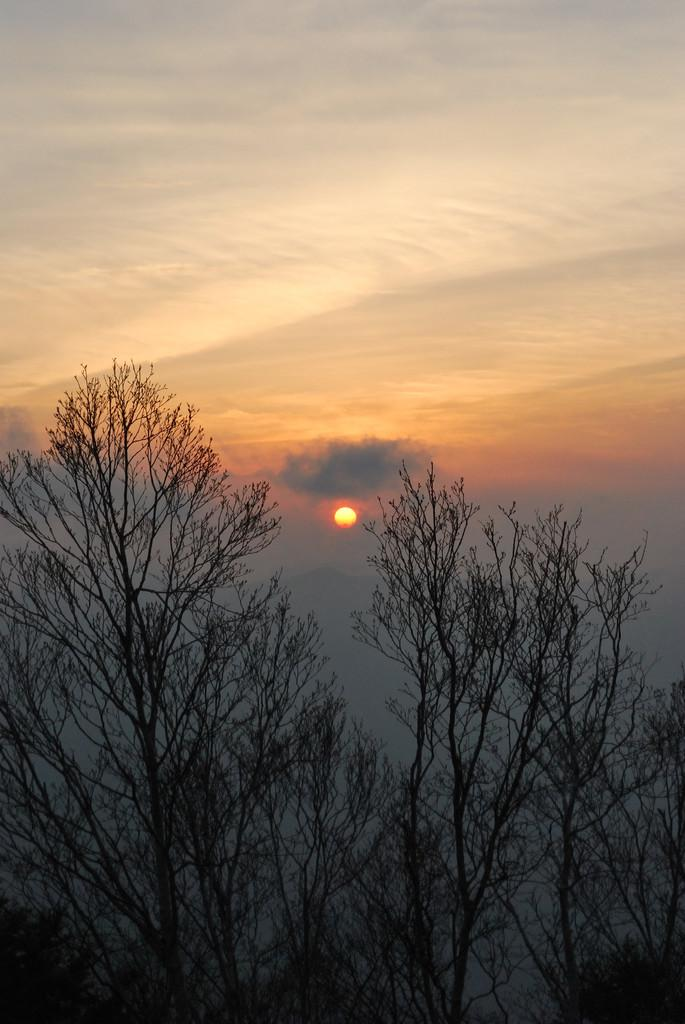What type of vegetation can be seen in the image? There are trees in the image. What is visible in the background of the image? The sky is visible in the background of the image. Can the sun be seen in the image? Yes, the sun is observable in the sky. What type of carriage can be seen in the image? There is no carriage present in the image. How many nerves are visible in the image? There are no nerves visible in the image, as it features trees and the sky. 